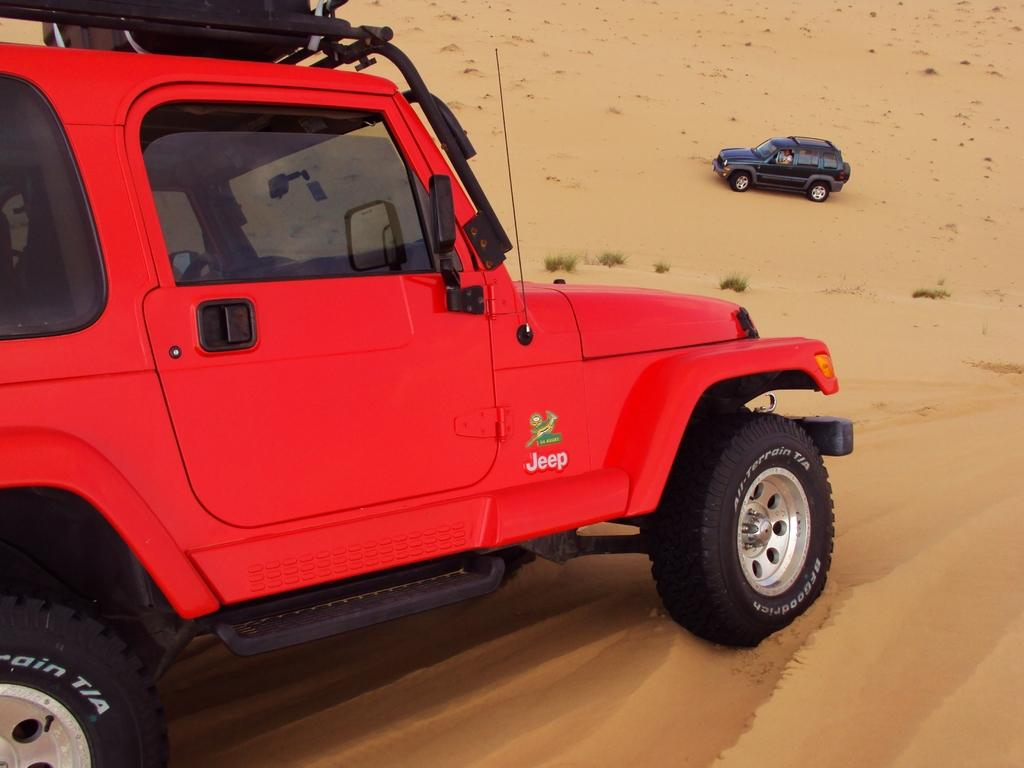What can be seen on the sand in the image? There are two vehicles on the sand in the image. What is visible in the background of the image? There are plants visible in the background. Can you describe the occupancy of the vehicles? There is a person inside one of the vehicles. What type of surprise is the person in the vehicle planning for the plants in the background? There is no indication in the image that the person in the vehicle is planning a surprise for the plants in the background. 